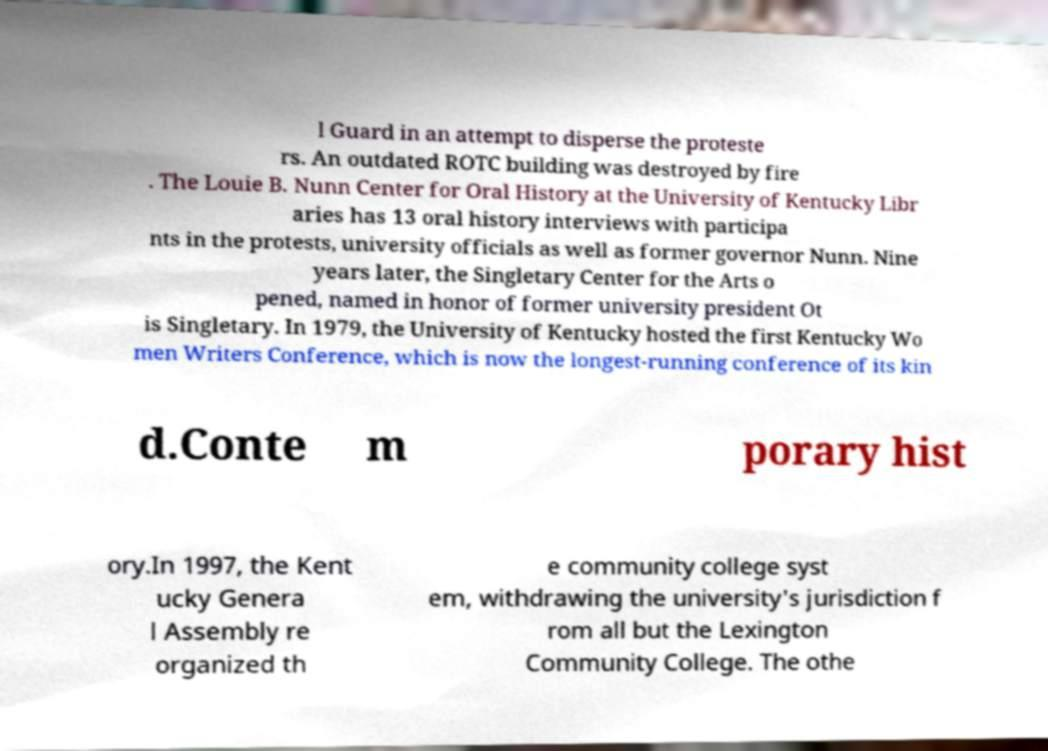For documentation purposes, I need the text within this image transcribed. Could you provide that? l Guard in an attempt to disperse the proteste rs. An outdated ROTC building was destroyed by fire . The Louie B. Nunn Center for Oral History at the University of Kentucky Libr aries has 13 oral history interviews with participa nts in the protests, university officials as well as former governor Nunn. Nine years later, the Singletary Center for the Arts o pened, named in honor of former university president Ot is Singletary. In 1979, the University of Kentucky hosted the first Kentucky Wo men Writers Conference, which is now the longest-running conference of its kin d.Conte m porary hist ory.In 1997, the Kent ucky Genera l Assembly re organized th e community college syst em, withdrawing the university's jurisdiction f rom all but the Lexington Community College. The othe 